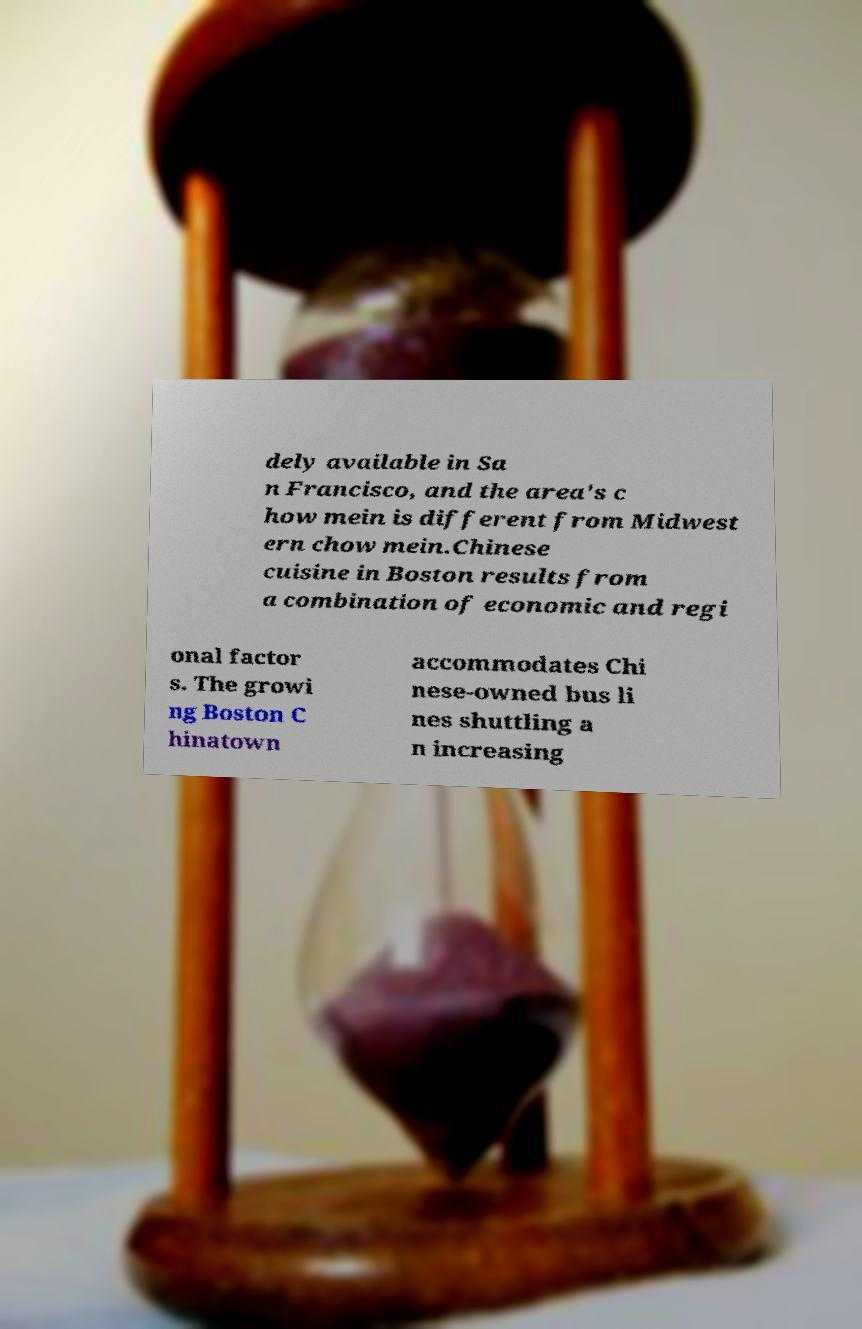There's text embedded in this image that I need extracted. Can you transcribe it verbatim? dely available in Sa n Francisco, and the area's c how mein is different from Midwest ern chow mein.Chinese cuisine in Boston results from a combination of economic and regi onal factor s. The growi ng Boston C hinatown accommodates Chi nese-owned bus li nes shuttling a n increasing 